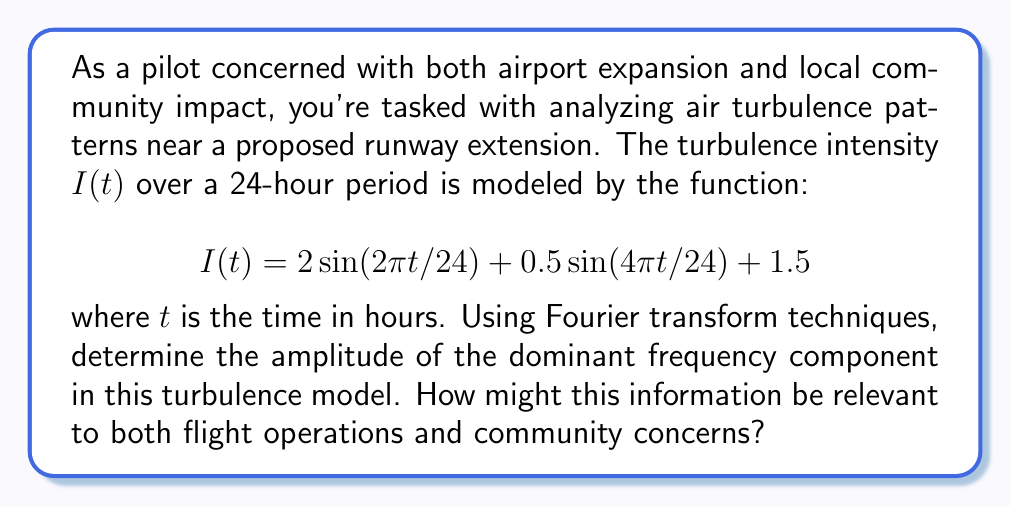Solve this math problem. To solve this problem, we'll follow these steps:

1) Identify the components of the given function:
   The function $I(t) = 2 \sin(2\pi t/24) + 0.5 \sin(4\pi t/24) + 1.5$ consists of two sinusoidal terms and a constant term.

2) Recognize that this is already in the form of a Fourier series:
   $$I(t) = A_0 + A_1 \sin(\omega_1 t) + A_2 \sin(\omega_2 t)$$
   where $A_0 = 1.5$ (constant term)
         $A_1 = 2$, $\omega_1 = 2\pi/24$
         $A_2 = 0.5$, $\omega_2 = 4\pi/24 = 2\omega_1$

3) The amplitudes of the frequency components are directly given by $A_1$ and $A_2$.

4) Compare the amplitudes:
   $A_1 = 2$ (for the fundamental frequency $\omega_1$)
   $A_2 = 0.5$ (for the second harmonic $2\omega_1$)

5) The dominant frequency component is the one with the larger amplitude, which is $A_1 = 2$.

This information is relevant to flight operations as it indicates that the turbulence intensity varies most significantly on a 24-hour cycle (corresponding to $\omega_1 = 2\pi/24$). For community concerns, it suggests that noise and disturbance patterns might also follow this daily cycle, potentially affecting sleep patterns and quality of life for nearby residents.
Answer: The amplitude of the dominant frequency component is 2. 